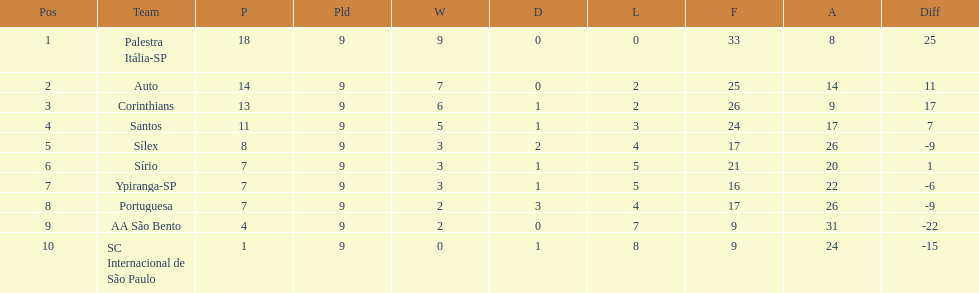Which is the only team to score 13 points in 9 games? Corinthians. 